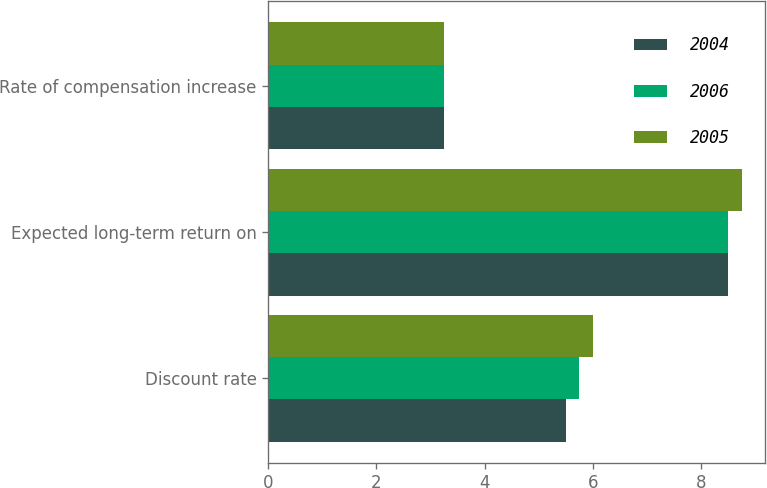Convert chart to OTSL. <chart><loc_0><loc_0><loc_500><loc_500><stacked_bar_chart><ecel><fcel>Discount rate<fcel>Expected long-term return on<fcel>Rate of compensation increase<nl><fcel>2004<fcel>5.5<fcel>8.5<fcel>3.25<nl><fcel>2006<fcel>5.75<fcel>8.5<fcel>3.25<nl><fcel>2005<fcel>6<fcel>8.75<fcel>3.25<nl></chart> 